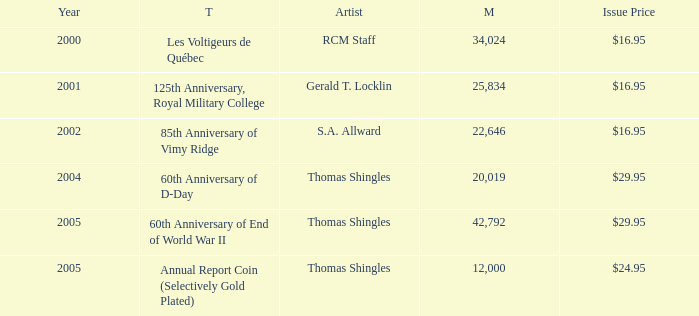Write the full table. {'header': ['Year', 'T', 'Artist', 'M', 'Issue Price'], 'rows': [['2000', 'Les Voltigeurs de Québec', 'RCM Staff', '34,024', '$16.95'], ['2001', '125th Anniversary, Royal Military College', 'Gerald T. Locklin', '25,834', '$16.95'], ['2002', '85th Anniversary of Vimy Ridge', 'S.A. Allward', '22,646', '$16.95'], ['2004', '60th Anniversary of D-Day', 'Thomas Shingles', '20,019', '$29.95'], ['2005', '60th Anniversary of End of World War II', 'Thomas Shingles', '42,792', '$29.95'], ['2005', 'Annual Report Coin (Selectively Gold Plated)', 'Thomas Shingles', '12,000', '$24.95']]} What year was S.A. Allward's theme that had an issue price of $16.95 released? 2002.0. 